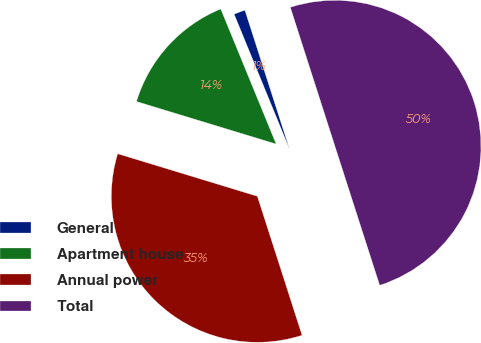Convert chart. <chart><loc_0><loc_0><loc_500><loc_500><pie_chart><fcel>General<fcel>Apartment house<fcel>Annual power<fcel>Total<nl><fcel>1.25%<fcel>14.1%<fcel>34.66%<fcel>50.0%<nl></chart> 